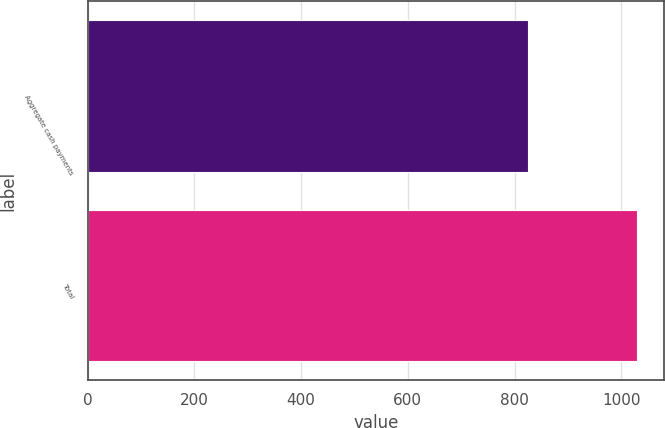Convert chart to OTSL. <chart><loc_0><loc_0><loc_500><loc_500><bar_chart><fcel>Aggregate cash payments<fcel>Total<nl><fcel>825<fcel>1029<nl></chart> 